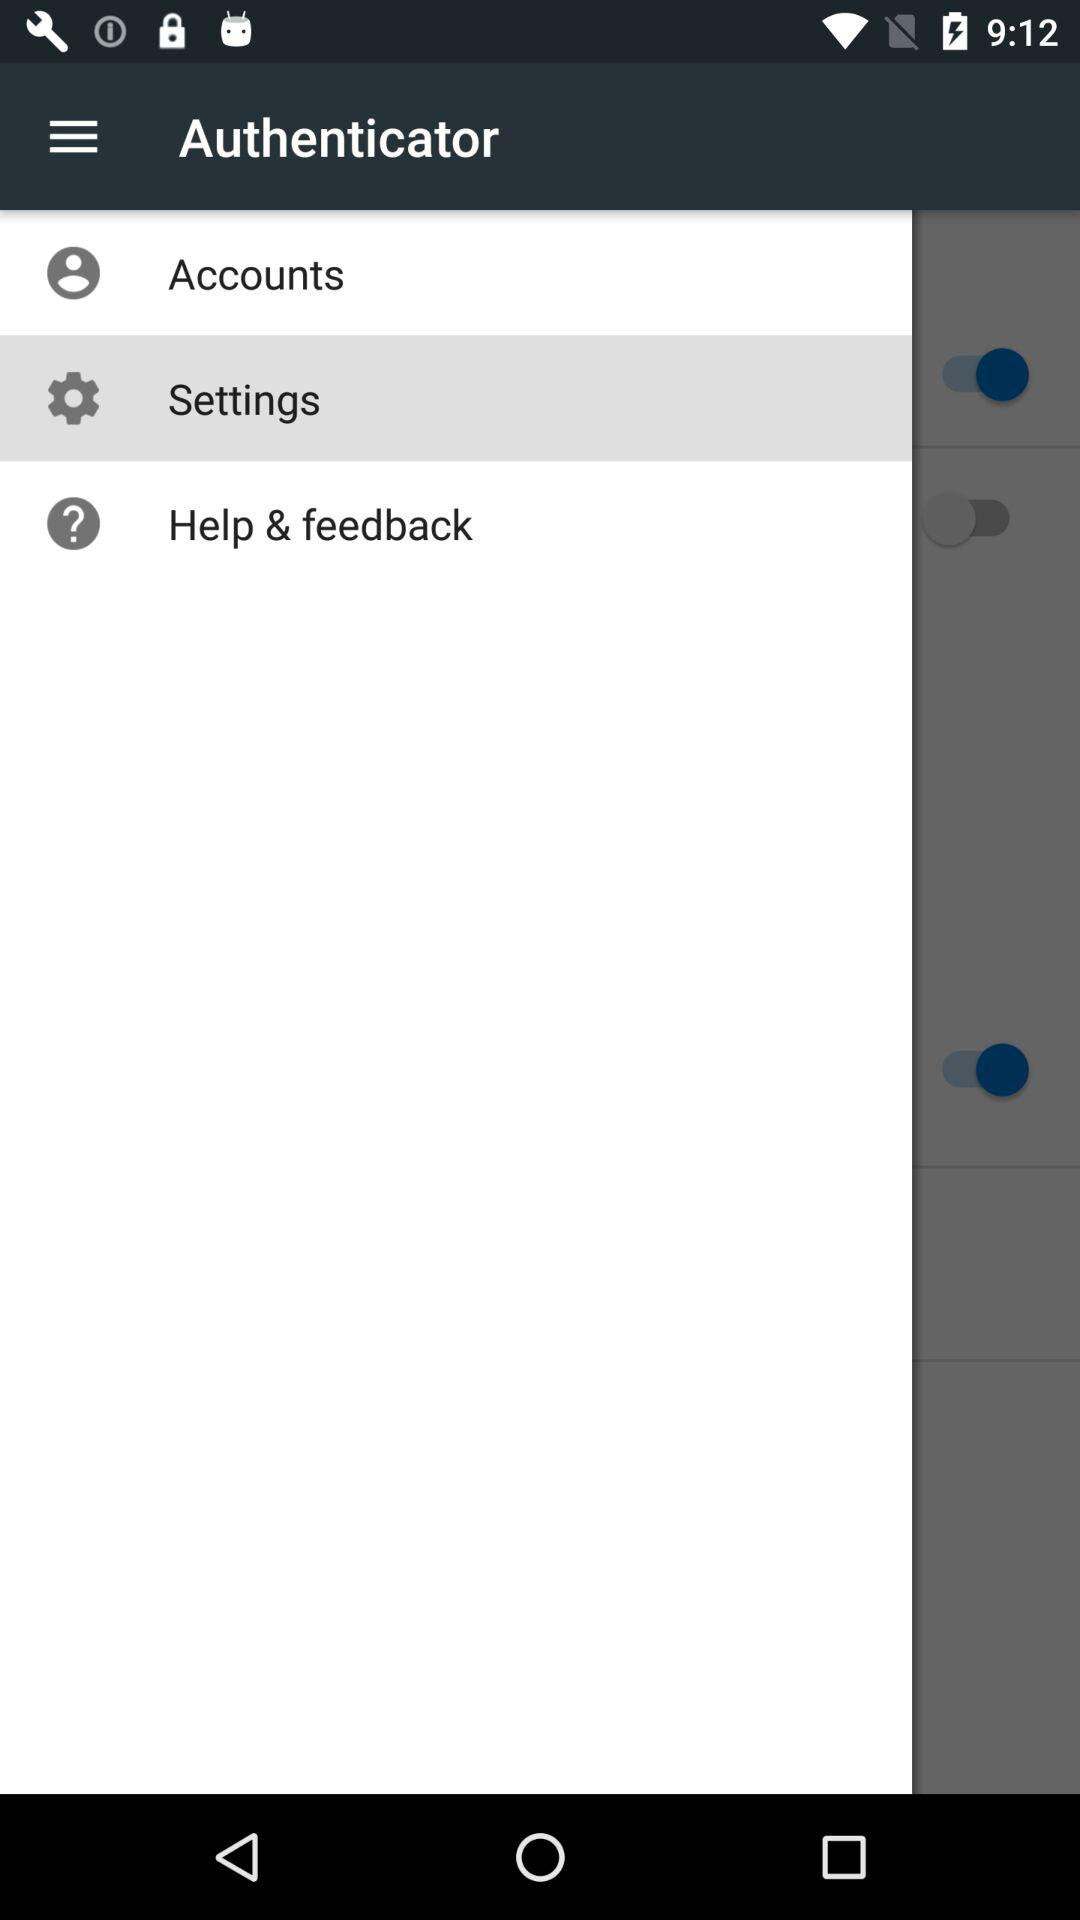How many switches are there on the screen?
Answer the question using a single word or phrase. 3 